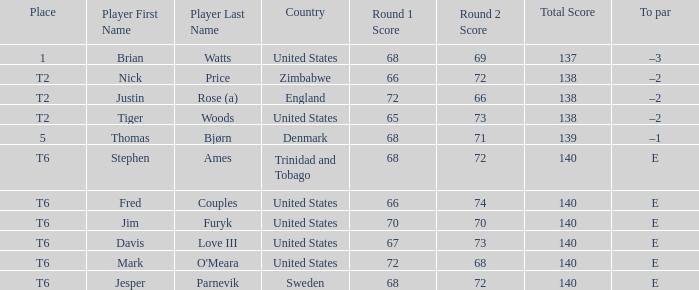Parse the table in full. {'header': ['Place', 'Player First Name', 'Player Last Name', 'Country', 'Round 1 Score', 'Round 2 Score', 'Total Score', 'To par'], 'rows': [['1', 'Brian', 'Watts', 'United States', '68', '69', '137', '–3'], ['T2', 'Nick', 'Price', 'Zimbabwe', '66', '72', '138', '–2'], ['T2', 'Justin', 'Rose (a)', 'England', '72', '66', '138', '–2'], ['T2', 'Tiger', 'Woods', 'United States', '65', '73', '138', '–2'], ['5', 'Thomas', 'Bjørn', 'Denmark', '68', '71', '139', '–1'], ['T6', 'Stephen', 'Ames', 'Trinidad and Tobago', '68', '72', '140', 'E'], ['T6', 'Fred', 'Couples', 'United States', '66', '74', '140', 'E'], ['T6', 'Jim', 'Furyk', 'United States', '70', '70', '140', 'E'], ['T6', 'Davis', 'Love III', 'United States', '67', '73', '140', 'E'], ['T6', 'Mark', "O'Meara", 'United States', '72', '68', '140', 'E'], ['T6', 'Jesper', 'Parnevik', 'Sweden', '68', '72', '140', 'E']]} What was the to par for the player with a score of 68-69=137? –3. 